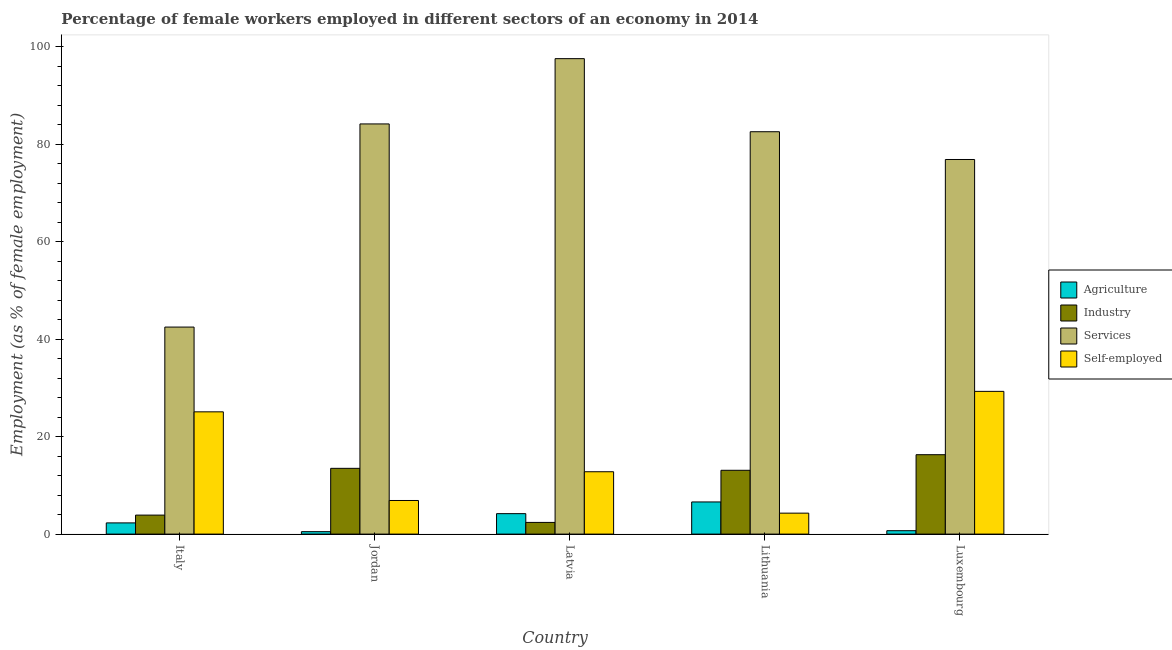What is the percentage of female workers in industry in Lithuania?
Give a very brief answer. 13.1. Across all countries, what is the maximum percentage of female workers in services?
Provide a succinct answer. 97.6. Across all countries, what is the minimum percentage of female workers in industry?
Make the answer very short. 2.4. In which country was the percentage of self employed female workers maximum?
Offer a very short reply. Luxembourg. What is the total percentage of female workers in industry in the graph?
Your answer should be very brief. 49.2. What is the difference between the percentage of female workers in agriculture in Italy and that in Luxembourg?
Keep it short and to the point. 1.6. What is the difference between the percentage of female workers in agriculture in Luxembourg and the percentage of self employed female workers in Lithuania?
Keep it short and to the point. -3.6. What is the average percentage of self employed female workers per country?
Provide a short and direct response. 15.68. What is the difference between the percentage of female workers in services and percentage of female workers in industry in Jordan?
Provide a short and direct response. 70.7. What is the ratio of the percentage of female workers in agriculture in Italy to that in Lithuania?
Provide a succinct answer. 0.35. Is the percentage of female workers in industry in Italy less than that in Lithuania?
Offer a very short reply. Yes. Is the difference between the percentage of female workers in industry in Italy and Lithuania greater than the difference between the percentage of female workers in agriculture in Italy and Lithuania?
Make the answer very short. No. What is the difference between the highest and the second highest percentage of female workers in agriculture?
Keep it short and to the point. 2.4. What is the difference between the highest and the lowest percentage of female workers in agriculture?
Offer a terse response. 6.1. In how many countries, is the percentage of female workers in agriculture greater than the average percentage of female workers in agriculture taken over all countries?
Keep it short and to the point. 2. Is the sum of the percentage of female workers in services in Italy and Latvia greater than the maximum percentage of self employed female workers across all countries?
Provide a short and direct response. Yes. What does the 2nd bar from the left in Luxembourg represents?
Your answer should be compact. Industry. What does the 1st bar from the right in Jordan represents?
Your answer should be compact. Self-employed. Are all the bars in the graph horizontal?
Ensure brevity in your answer.  No. How many countries are there in the graph?
Make the answer very short. 5. What is the difference between two consecutive major ticks on the Y-axis?
Make the answer very short. 20. Does the graph contain any zero values?
Provide a short and direct response. No. Where does the legend appear in the graph?
Provide a short and direct response. Center right. How many legend labels are there?
Provide a succinct answer. 4. How are the legend labels stacked?
Offer a terse response. Vertical. What is the title of the graph?
Offer a very short reply. Percentage of female workers employed in different sectors of an economy in 2014. What is the label or title of the X-axis?
Offer a terse response. Country. What is the label or title of the Y-axis?
Provide a succinct answer. Employment (as % of female employment). What is the Employment (as % of female employment) of Agriculture in Italy?
Make the answer very short. 2.3. What is the Employment (as % of female employment) in Industry in Italy?
Your response must be concise. 3.9. What is the Employment (as % of female employment) in Services in Italy?
Give a very brief answer. 42.5. What is the Employment (as % of female employment) of Self-employed in Italy?
Keep it short and to the point. 25.1. What is the Employment (as % of female employment) in Services in Jordan?
Provide a short and direct response. 84.2. What is the Employment (as % of female employment) in Self-employed in Jordan?
Ensure brevity in your answer.  6.9. What is the Employment (as % of female employment) in Agriculture in Latvia?
Provide a succinct answer. 4.2. What is the Employment (as % of female employment) in Industry in Latvia?
Make the answer very short. 2.4. What is the Employment (as % of female employment) in Services in Latvia?
Offer a terse response. 97.6. What is the Employment (as % of female employment) of Self-employed in Latvia?
Provide a succinct answer. 12.8. What is the Employment (as % of female employment) in Agriculture in Lithuania?
Your response must be concise. 6.6. What is the Employment (as % of female employment) of Industry in Lithuania?
Ensure brevity in your answer.  13.1. What is the Employment (as % of female employment) of Services in Lithuania?
Keep it short and to the point. 82.6. What is the Employment (as % of female employment) in Self-employed in Lithuania?
Provide a short and direct response. 4.3. What is the Employment (as % of female employment) in Agriculture in Luxembourg?
Give a very brief answer. 0.7. What is the Employment (as % of female employment) in Industry in Luxembourg?
Make the answer very short. 16.3. What is the Employment (as % of female employment) of Services in Luxembourg?
Offer a terse response. 76.9. What is the Employment (as % of female employment) in Self-employed in Luxembourg?
Ensure brevity in your answer.  29.3. Across all countries, what is the maximum Employment (as % of female employment) in Agriculture?
Ensure brevity in your answer.  6.6. Across all countries, what is the maximum Employment (as % of female employment) in Industry?
Provide a short and direct response. 16.3. Across all countries, what is the maximum Employment (as % of female employment) of Services?
Offer a very short reply. 97.6. Across all countries, what is the maximum Employment (as % of female employment) of Self-employed?
Keep it short and to the point. 29.3. Across all countries, what is the minimum Employment (as % of female employment) in Agriculture?
Provide a succinct answer. 0.5. Across all countries, what is the minimum Employment (as % of female employment) of Industry?
Make the answer very short. 2.4. Across all countries, what is the minimum Employment (as % of female employment) of Services?
Offer a very short reply. 42.5. Across all countries, what is the minimum Employment (as % of female employment) in Self-employed?
Give a very brief answer. 4.3. What is the total Employment (as % of female employment) of Industry in the graph?
Make the answer very short. 49.2. What is the total Employment (as % of female employment) in Services in the graph?
Offer a terse response. 383.8. What is the total Employment (as % of female employment) in Self-employed in the graph?
Your response must be concise. 78.4. What is the difference between the Employment (as % of female employment) of Agriculture in Italy and that in Jordan?
Your answer should be compact. 1.8. What is the difference between the Employment (as % of female employment) of Services in Italy and that in Jordan?
Make the answer very short. -41.7. What is the difference between the Employment (as % of female employment) of Agriculture in Italy and that in Latvia?
Your response must be concise. -1.9. What is the difference between the Employment (as % of female employment) in Industry in Italy and that in Latvia?
Keep it short and to the point. 1.5. What is the difference between the Employment (as % of female employment) of Services in Italy and that in Latvia?
Your response must be concise. -55.1. What is the difference between the Employment (as % of female employment) in Agriculture in Italy and that in Lithuania?
Your answer should be compact. -4.3. What is the difference between the Employment (as % of female employment) of Services in Italy and that in Lithuania?
Provide a short and direct response. -40.1. What is the difference between the Employment (as % of female employment) in Self-employed in Italy and that in Lithuania?
Offer a very short reply. 20.8. What is the difference between the Employment (as % of female employment) of Industry in Italy and that in Luxembourg?
Make the answer very short. -12.4. What is the difference between the Employment (as % of female employment) of Services in Italy and that in Luxembourg?
Your answer should be very brief. -34.4. What is the difference between the Employment (as % of female employment) in Agriculture in Jordan and that in Latvia?
Your answer should be compact. -3.7. What is the difference between the Employment (as % of female employment) of Services in Jordan and that in Latvia?
Keep it short and to the point. -13.4. What is the difference between the Employment (as % of female employment) of Industry in Jordan and that in Lithuania?
Provide a succinct answer. 0.4. What is the difference between the Employment (as % of female employment) in Services in Jordan and that in Lithuania?
Your answer should be compact. 1.6. What is the difference between the Employment (as % of female employment) in Self-employed in Jordan and that in Lithuania?
Provide a short and direct response. 2.6. What is the difference between the Employment (as % of female employment) of Industry in Jordan and that in Luxembourg?
Ensure brevity in your answer.  -2.8. What is the difference between the Employment (as % of female employment) of Services in Jordan and that in Luxembourg?
Offer a very short reply. 7.3. What is the difference between the Employment (as % of female employment) in Self-employed in Jordan and that in Luxembourg?
Offer a terse response. -22.4. What is the difference between the Employment (as % of female employment) in Services in Latvia and that in Lithuania?
Ensure brevity in your answer.  15. What is the difference between the Employment (as % of female employment) of Self-employed in Latvia and that in Lithuania?
Offer a terse response. 8.5. What is the difference between the Employment (as % of female employment) in Agriculture in Latvia and that in Luxembourg?
Provide a succinct answer. 3.5. What is the difference between the Employment (as % of female employment) in Industry in Latvia and that in Luxembourg?
Ensure brevity in your answer.  -13.9. What is the difference between the Employment (as % of female employment) of Services in Latvia and that in Luxembourg?
Ensure brevity in your answer.  20.7. What is the difference between the Employment (as % of female employment) of Self-employed in Latvia and that in Luxembourg?
Ensure brevity in your answer.  -16.5. What is the difference between the Employment (as % of female employment) in Agriculture in Lithuania and that in Luxembourg?
Make the answer very short. 5.9. What is the difference between the Employment (as % of female employment) of Services in Lithuania and that in Luxembourg?
Ensure brevity in your answer.  5.7. What is the difference between the Employment (as % of female employment) of Agriculture in Italy and the Employment (as % of female employment) of Services in Jordan?
Your response must be concise. -81.9. What is the difference between the Employment (as % of female employment) of Industry in Italy and the Employment (as % of female employment) of Services in Jordan?
Make the answer very short. -80.3. What is the difference between the Employment (as % of female employment) in Industry in Italy and the Employment (as % of female employment) in Self-employed in Jordan?
Ensure brevity in your answer.  -3. What is the difference between the Employment (as % of female employment) in Services in Italy and the Employment (as % of female employment) in Self-employed in Jordan?
Provide a short and direct response. 35.6. What is the difference between the Employment (as % of female employment) of Agriculture in Italy and the Employment (as % of female employment) of Industry in Latvia?
Provide a short and direct response. -0.1. What is the difference between the Employment (as % of female employment) in Agriculture in Italy and the Employment (as % of female employment) in Services in Latvia?
Offer a very short reply. -95.3. What is the difference between the Employment (as % of female employment) in Industry in Italy and the Employment (as % of female employment) in Services in Latvia?
Your answer should be very brief. -93.7. What is the difference between the Employment (as % of female employment) in Services in Italy and the Employment (as % of female employment) in Self-employed in Latvia?
Your answer should be compact. 29.7. What is the difference between the Employment (as % of female employment) in Agriculture in Italy and the Employment (as % of female employment) in Services in Lithuania?
Keep it short and to the point. -80.3. What is the difference between the Employment (as % of female employment) in Agriculture in Italy and the Employment (as % of female employment) in Self-employed in Lithuania?
Your response must be concise. -2. What is the difference between the Employment (as % of female employment) of Industry in Italy and the Employment (as % of female employment) of Services in Lithuania?
Make the answer very short. -78.7. What is the difference between the Employment (as % of female employment) of Industry in Italy and the Employment (as % of female employment) of Self-employed in Lithuania?
Offer a terse response. -0.4. What is the difference between the Employment (as % of female employment) of Services in Italy and the Employment (as % of female employment) of Self-employed in Lithuania?
Offer a very short reply. 38.2. What is the difference between the Employment (as % of female employment) in Agriculture in Italy and the Employment (as % of female employment) in Services in Luxembourg?
Your response must be concise. -74.6. What is the difference between the Employment (as % of female employment) of Agriculture in Italy and the Employment (as % of female employment) of Self-employed in Luxembourg?
Offer a very short reply. -27. What is the difference between the Employment (as % of female employment) in Industry in Italy and the Employment (as % of female employment) in Services in Luxembourg?
Make the answer very short. -73. What is the difference between the Employment (as % of female employment) in Industry in Italy and the Employment (as % of female employment) in Self-employed in Luxembourg?
Offer a very short reply. -25.4. What is the difference between the Employment (as % of female employment) in Services in Italy and the Employment (as % of female employment) in Self-employed in Luxembourg?
Your response must be concise. 13.2. What is the difference between the Employment (as % of female employment) of Agriculture in Jordan and the Employment (as % of female employment) of Industry in Latvia?
Ensure brevity in your answer.  -1.9. What is the difference between the Employment (as % of female employment) of Agriculture in Jordan and the Employment (as % of female employment) of Services in Latvia?
Ensure brevity in your answer.  -97.1. What is the difference between the Employment (as % of female employment) in Industry in Jordan and the Employment (as % of female employment) in Services in Latvia?
Your answer should be very brief. -84.1. What is the difference between the Employment (as % of female employment) in Services in Jordan and the Employment (as % of female employment) in Self-employed in Latvia?
Make the answer very short. 71.4. What is the difference between the Employment (as % of female employment) in Agriculture in Jordan and the Employment (as % of female employment) in Industry in Lithuania?
Your answer should be compact. -12.6. What is the difference between the Employment (as % of female employment) in Agriculture in Jordan and the Employment (as % of female employment) in Services in Lithuania?
Offer a terse response. -82.1. What is the difference between the Employment (as % of female employment) of Agriculture in Jordan and the Employment (as % of female employment) of Self-employed in Lithuania?
Keep it short and to the point. -3.8. What is the difference between the Employment (as % of female employment) of Industry in Jordan and the Employment (as % of female employment) of Services in Lithuania?
Give a very brief answer. -69.1. What is the difference between the Employment (as % of female employment) of Industry in Jordan and the Employment (as % of female employment) of Self-employed in Lithuania?
Your response must be concise. 9.2. What is the difference between the Employment (as % of female employment) in Services in Jordan and the Employment (as % of female employment) in Self-employed in Lithuania?
Ensure brevity in your answer.  79.9. What is the difference between the Employment (as % of female employment) of Agriculture in Jordan and the Employment (as % of female employment) of Industry in Luxembourg?
Provide a succinct answer. -15.8. What is the difference between the Employment (as % of female employment) in Agriculture in Jordan and the Employment (as % of female employment) in Services in Luxembourg?
Your response must be concise. -76.4. What is the difference between the Employment (as % of female employment) of Agriculture in Jordan and the Employment (as % of female employment) of Self-employed in Luxembourg?
Keep it short and to the point. -28.8. What is the difference between the Employment (as % of female employment) in Industry in Jordan and the Employment (as % of female employment) in Services in Luxembourg?
Give a very brief answer. -63.4. What is the difference between the Employment (as % of female employment) in Industry in Jordan and the Employment (as % of female employment) in Self-employed in Luxembourg?
Provide a succinct answer. -15.8. What is the difference between the Employment (as % of female employment) in Services in Jordan and the Employment (as % of female employment) in Self-employed in Luxembourg?
Provide a short and direct response. 54.9. What is the difference between the Employment (as % of female employment) in Agriculture in Latvia and the Employment (as % of female employment) in Services in Lithuania?
Your answer should be very brief. -78.4. What is the difference between the Employment (as % of female employment) of Agriculture in Latvia and the Employment (as % of female employment) of Self-employed in Lithuania?
Give a very brief answer. -0.1. What is the difference between the Employment (as % of female employment) of Industry in Latvia and the Employment (as % of female employment) of Services in Lithuania?
Make the answer very short. -80.2. What is the difference between the Employment (as % of female employment) of Industry in Latvia and the Employment (as % of female employment) of Self-employed in Lithuania?
Offer a very short reply. -1.9. What is the difference between the Employment (as % of female employment) in Services in Latvia and the Employment (as % of female employment) in Self-employed in Lithuania?
Your answer should be compact. 93.3. What is the difference between the Employment (as % of female employment) in Agriculture in Latvia and the Employment (as % of female employment) in Industry in Luxembourg?
Offer a very short reply. -12.1. What is the difference between the Employment (as % of female employment) of Agriculture in Latvia and the Employment (as % of female employment) of Services in Luxembourg?
Keep it short and to the point. -72.7. What is the difference between the Employment (as % of female employment) of Agriculture in Latvia and the Employment (as % of female employment) of Self-employed in Luxembourg?
Ensure brevity in your answer.  -25.1. What is the difference between the Employment (as % of female employment) of Industry in Latvia and the Employment (as % of female employment) of Services in Luxembourg?
Offer a terse response. -74.5. What is the difference between the Employment (as % of female employment) of Industry in Latvia and the Employment (as % of female employment) of Self-employed in Luxembourg?
Make the answer very short. -26.9. What is the difference between the Employment (as % of female employment) in Services in Latvia and the Employment (as % of female employment) in Self-employed in Luxembourg?
Your answer should be compact. 68.3. What is the difference between the Employment (as % of female employment) of Agriculture in Lithuania and the Employment (as % of female employment) of Services in Luxembourg?
Offer a very short reply. -70.3. What is the difference between the Employment (as % of female employment) of Agriculture in Lithuania and the Employment (as % of female employment) of Self-employed in Luxembourg?
Keep it short and to the point. -22.7. What is the difference between the Employment (as % of female employment) in Industry in Lithuania and the Employment (as % of female employment) in Services in Luxembourg?
Provide a short and direct response. -63.8. What is the difference between the Employment (as % of female employment) of Industry in Lithuania and the Employment (as % of female employment) of Self-employed in Luxembourg?
Your answer should be compact. -16.2. What is the difference between the Employment (as % of female employment) in Services in Lithuania and the Employment (as % of female employment) in Self-employed in Luxembourg?
Ensure brevity in your answer.  53.3. What is the average Employment (as % of female employment) of Agriculture per country?
Your answer should be compact. 2.86. What is the average Employment (as % of female employment) of Industry per country?
Your response must be concise. 9.84. What is the average Employment (as % of female employment) of Services per country?
Keep it short and to the point. 76.76. What is the average Employment (as % of female employment) of Self-employed per country?
Provide a succinct answer. 15.68. What is the difference between the Employment (as % of female employment) of Agriculture and Employment (as % of female employment) of Services in Italy?
Offer a very short reply. -40.2. What is the difference between the Employment (as % of female employment) in Agriculture and Employment (as % of female employment) in Self-employed in Italy?
Keep it short and to the point. -22.8. What is the difference between the Employment (as % of female employment) of Industry and Employment (as % of female employment) of Services in Italy?
Give a very brief answer. -38.6. What is the difference between the Employment (as % of female employment) in Industry and Employment (as % of female employment) in Self-employed in Italy?
Provide a succinct answer. -21.2. What is the difference between the Employment (as % of female employment) in Services and Employment (as % of female employment) in Self-employed in Italy?
Provide a succinct answer. 17.4. What is the difference between the Employment (as % of female employment) in Agriculture and Employment (as % of female employment) in Services in Jordan?
Make the answer very short. -83.7. What is the difference between the Employment (as % of female employment) of Agriculture and Employment (as % of female employment) of Self-employed in Jordan?
Provide a succinct answer. -6.4. What is the difference between the Employment (as % of female employment) in Industry and Employment (as % of female employment) in Services in Jordan?
Your answer should be compact. -70.7. What is the difference between the Employment (as % of female employment) of Services and Employment (as % of female employment) of Self-employed in Jordan?
Offer a terse response. 77.3. What is the difference between the Employment (as % of female employment) of Agriculture and Employment (as % of female employment) of Services in Latvia?
Offer a terse response. -93.4. What is the difference between the Employment (as % of female employment) of Industry and Employment (as % of female employment) of Services in Latvia?
Your answer should be very brief. -95.2. What is the difference between the Employment (as % of female employment) of Services and Employment (as % of female employment) of Self-employed in Latvia?
Provide a short and direct response. 84.8. What is the difference between the Employment (as % of female employment) in Agriculture and Employment (as % of female employment) in Industry in Lithuania?
Offer a terse response. -6.5. What is the difference between the Employment (as % of female employment) of Agriculture and Employment (as % of female employment) of Services in Lithuania?
Offer a very short reply. -76. What is the difference between the Employment (as % of female employment) of Agriculture and Employment (as % of female employment) of Self-employed in Lithuania?
Keep it short and to the point. 2.3. What is the difference between the Employment (as % of female employment) of Industry and Employment (as % of female employment) of Services in Lithuania?
Give a very brief answer. -69.5. What is the difference between the Employment (as % of female employment) in Services and Employment (as % of female employment) in Self-employed in Lithuania?
Offer a very short reply. 78.3. What is the difference between the Employment (as % of female employment) in Agriculture and Employment (as % of female employment) in Industry in Luxembourg?
Ensure brevity in your answer.  -15.6. What is the difference between the Employment (as % of female employment) in Agriculture and Employment (as % of female employment) in Services in Luxembourg?
Make the answer very short. -76.2. What is the difference between the Employment (as % of female employment) of Agriculture and Employment (as % of female employment) of Self-employed in Luxembourg?
Make the answer very short. -28.6. What is the difference between the Employment (as % of female employment) in Industry and Employment (as % of female employment) in Services in Luxembourg?
Your answer should be very brief. -60.6. What is the difference between the Employment (as % of female employment) of Industry and Employment (as % of female employment) of Self-employed in Luxembourg?
Give a very brief answer. -13. What is the difference between the Employment (as % of female employment) of Services and Employment (as % of female employment) of Self-employed in Luxembourg?
Your response must be concise. 47.6. What is the ratio of the Employment (as % of female employment) in Agriculture in Italy to that in Jordan?
Offer a terse response. 4.6. What is the ratio of the Employment (as % of female employment) in Industry in Italy to that in Jordan?
Your answer should be compact. 0.29. What is the ratio of the Employment (as % of female employment) in Services in Italy to that in Jordan?
Offer a very short reply. 0.5. What is the ratio of the Employment (as % of female employment) in Self-employed in Italy to that in Jordan?
Keep it short and to the point. 3.64. What is the ratio of the Employment (as % of female employment) of Agriculture in Italy to that in Latvia?
Offer a very short reply. 0.55. What is the ratio of the Employment (as % of female employment) of Industry in Italy to that in Latvia?
Keep it short and to the point. 1.62. What is the ratio of the Employment (as % of female employment) of Services in Italy to that in Latvia?
Ensure brevity in your answer.  0.44. What is the ratio of the Employment (as % of female employment) of Self-employed in Italy to that in Latvia?
Ensure brevity in your answer.  1.96. What is the ratio of the Employment (as % of female employment) in Agriculture in Italy to that in Lithuania?
Your response must be concise. 0.35. What is the ratio of the Employment (as % of female employment) of Industry in Italy to that in Lithuania?
Give a very brief answer. 0.3. What is the ratio of the Employment (as % of female employment) of Services in Italy to that in Lithuania?
Offer a very short reply. 0.51. What is the ratio of the Employment (as % of female employment) of Self-employed in Italy to that in Lithuania?
Give a very brief answer. 5.84. What is the ratio of the Employment (as % of female employment) in Agriculture in Italy to that in Luxembourg?
Give a very brief answer. 3.29. What is the ratio of the Employment (as % of female employment) in Industry in Italy to that in Luxembourg?
Make the answer very short. 0.24. What is the ratio of the Employment (as % of female employment) in Services in Italy to that in Luxembourg?
Your answer should be very brief. 0.55. What is the ratio of the Employment (as % of female employment) in Self-employed in Italy to that in Luxembourg?
Give a very brief answer. 0.86. What is the ratio of the Employment (as % of female employment) in Agriculture in Jordan to that in Latvia?
Your answer should be compact. 0.12. What is the ratio of the Employment (as % of female employment) of Industry in Jordan to that in Latvia?
Offer a terse response. 5.62. What is the ratio of the Employment (as % of female employment) of Services in Jordan to that in Latvia?
Offer a very short reply. 0.86. What is the ratio of the Employment (as % of female employment) of Self-employed in Jordan to that in Latvia?
Give a very brief answer. 0.54. What is the ratio of the Employment (as % of female employment) of Agriculture in Jordan to that in Lithuania?
Offer a terse response. 0.08. What is the ratio of the Employment (as % of female employment) in Industry in Jordan to that in Lithuania?
Your answer should be compact. 1.03. What is the ratio of the Employment (as % of female employment) in Services in Jordan to that in Lithuania?
Offer a terse response. 1.02. What is the ratio of the Employment (as % of female employment) of Self-employed in Jordan to that in Lithuania?
Keep it short and to the point. 1.6. What is the ratio of the Employment (as % of female employment) of Agriculture in Jordan to that in Luxembourg?
Make the answer very short. 0.71. What is the ratio of the Employment (as % of female employment) of Industry in Jordan to that in Luxembourg?
Provide a succinct answer. 0.83. What is the ratio of the Employment (as % of female employment) in Services in Jordan to that in Luxembourg?
Make the answer very short. 1.09. What is the ratio of the Employment (as % of female employment) of Self-employed in Jordan to that in Luxembourg?
Your answer should be very brief. 0.24. What is the ratio of the Employment (as % of female employment) in Agriculture in Latvia to that in Lithuania?
Provide a succinct answer. 0.64. What is the ratio of the Employment (as % of female employment) in Industry in Latvia to that in Lithuania?
Your response must be concise. 0.18. What is the ratio of the Employment (as % of female employment) in Services in Latvia to that in Lithuania?
Offer a very short reply. 1.18. What is the ratio of the Employment (as % of female employment) in Self-employed in Latvia to that in Lithuania?
Your response must be concise. 2.98. What is the ratio of the Employment (as % of female employment) in Industry in Latvia to that in Luxembourg?
Keep it short and to the point. 0.15. What is the ratio of the Employment (as % of female employment) in Services in Latvia to that in Luxembourg?
Your answer should be compact. 1.27. What is the ratio of the Employment (as % of female employment) in Self-employed in Latvia to that in Luxembourg?
Provide a short and direct response. 0.44. What is the ratio of the Employment (as % of female employment) in Agriculture in Lithuania to that in Luxembourg?
Keep it short and to the point. 9.43. What is the ratio of the Employment (as % of female employment) of Industry in Lithuania to that in Luxembourg?
Your answer should be compact. 0.8. What is the ratio of the Employment (as % of female employment) in Services in Lithuania to that in Luxembourg?
Provide a short and direct response. 1.07. What is the ratio of the Employment (as % of female employment) in Self-employed in Lithuania to that in Luxembourg?
Your answer should be compact. 0.15. What is the difference between the highest and the second highest Employment (as % of female employment) in Services?
Give a very brief answer. 13.4. What is the difference between the highest and the lowest Employment (as % of female employment) in Services?
Your answer should be compact. 55.1. What is the difference between the highest and the lowest Employment (as % of female employment) of Self-employed?
Provide a short and direct response. 25. 